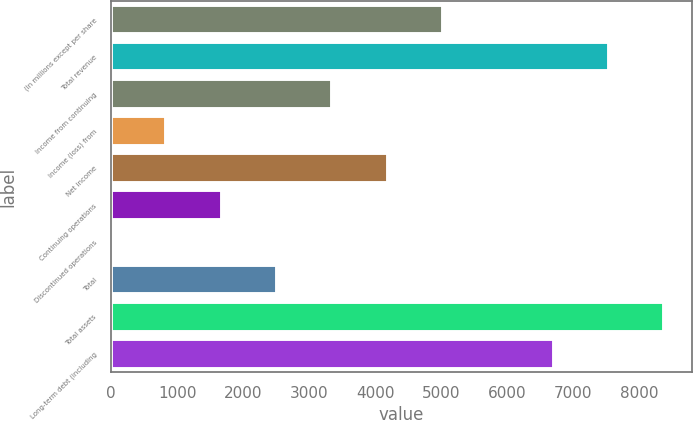Convert chart to OTSL. <chart><loc_0><loc_0><loc_500><loc_500><bar_chart><fcel>(In millions except per share<fcel>Total revenue<fcel>Income from continuing<fcel>Income (loss) from<fcel>Net income<fcel>Continuing operations<fcel>Discontinued operations<fcel>Total<fcel>Total assets<fcel>Long-term debt (including<nl><fcel>5026.82<fcel>7540.22<fcel>3351.22<fcel>837.82<fcel>4189.02<fcel>1675.62<fcel>0.02<fcel>2513.42<fcel>8378.02<fcel>6702.42<nl></chart> 